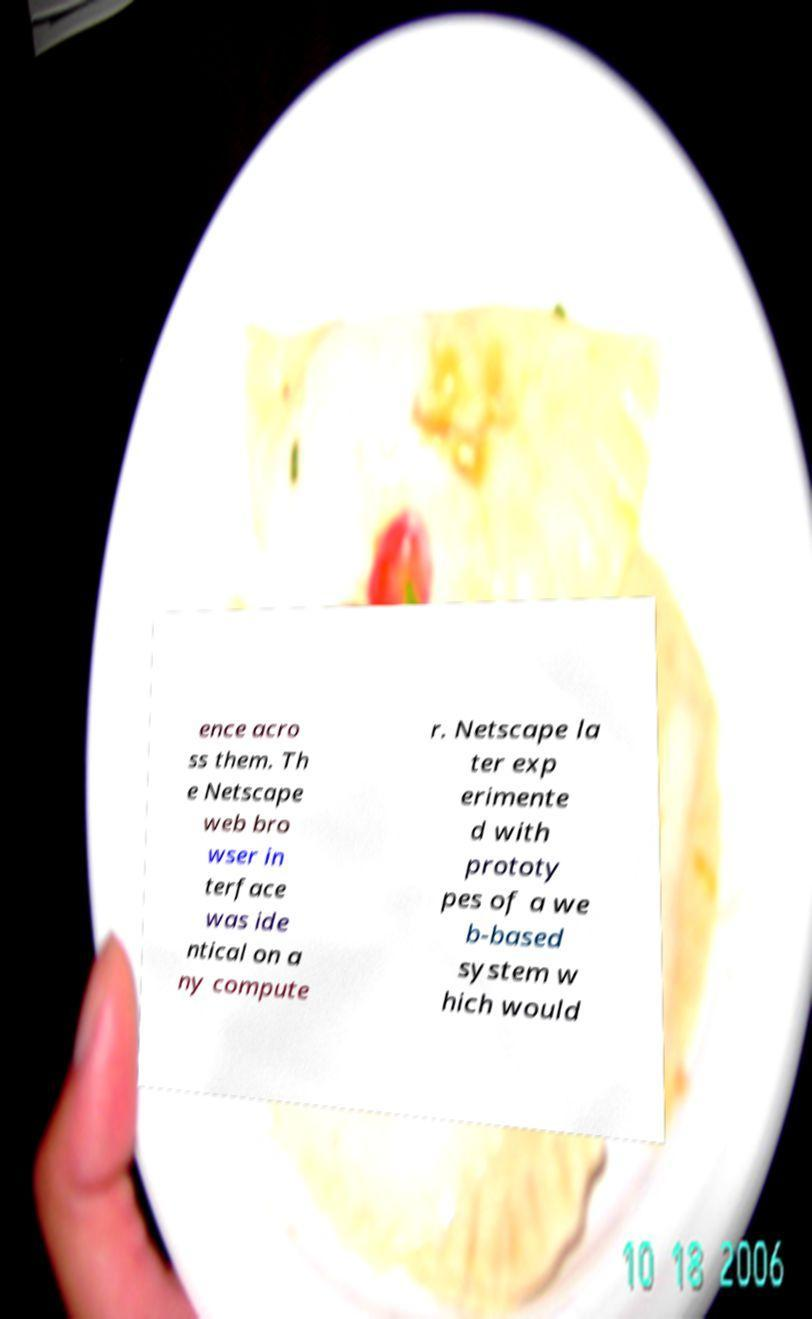I need the written content from this picture converted into text. Can you do that? ence acro ss them. Th e Netscape web bro wser in terface was ide ntical on a ny compute r. Netscape la ter exp erimente d with prototy pes of a we b-based system w hich would 